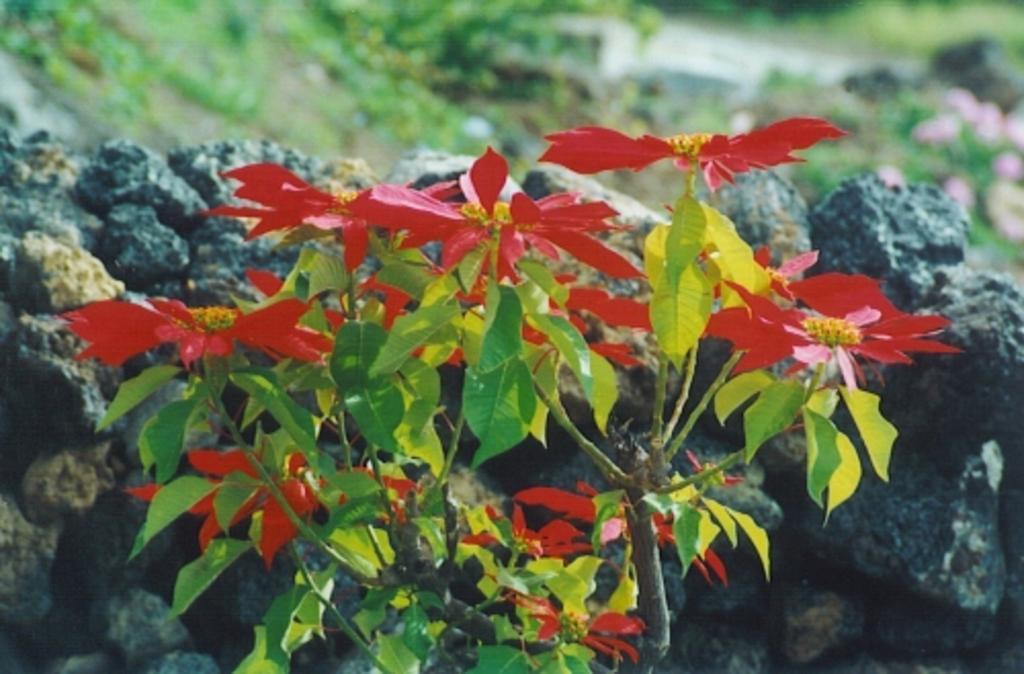Could you give a brief overview of what you see in this image? In this image in the foreground there are some flowers and plants, and in the background there are some rocks, grass, plants and flowers. 